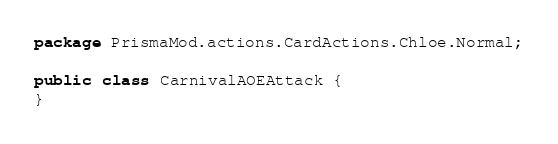<code> <loc_0><loc_0><loc_500><loc_500><_Java_>package PrismaMod.actions.CardActions.Chloe.Normal;

public class CarnivalAOEAttack {
}
</code> 